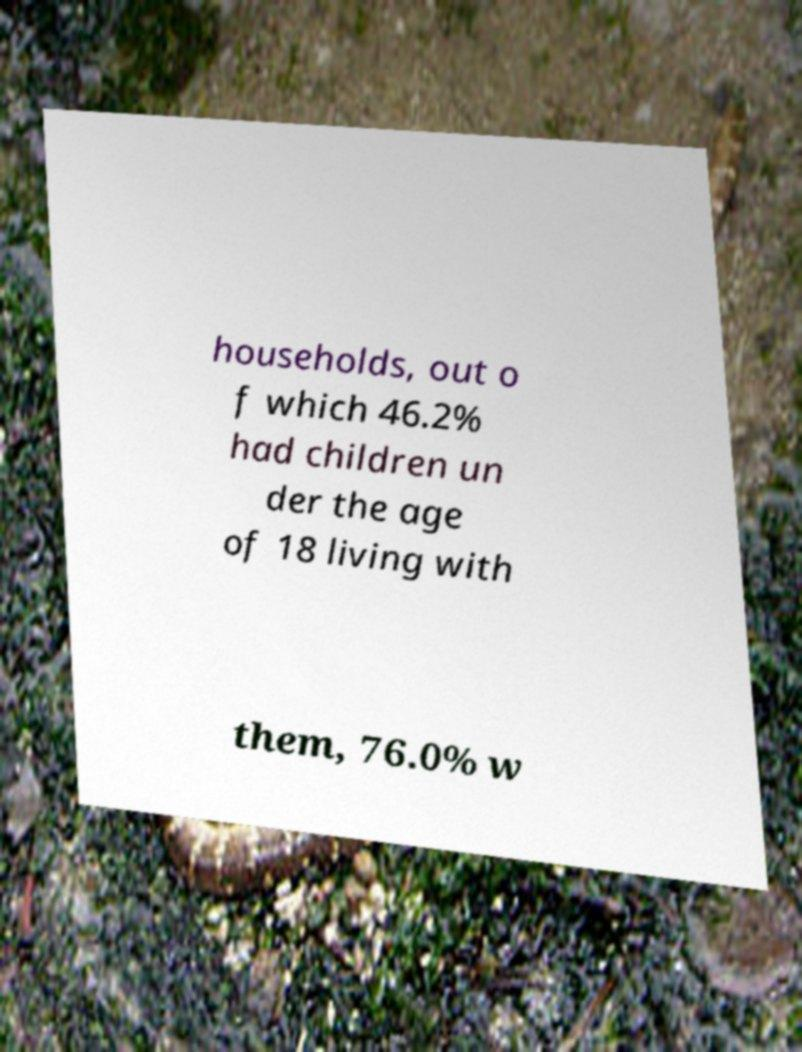Could you extract and type out the text from this image? households, out o f which 46.2% had children un der the age of 18 living with them, 76.0% w 